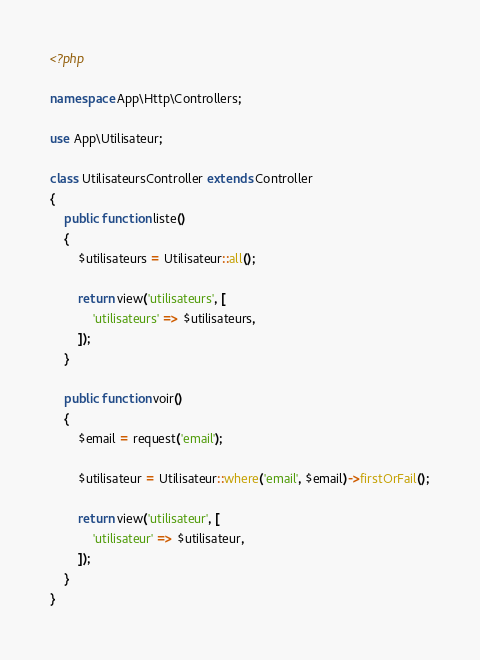Convert code to text. <code><loc_0><loc_0><loc_500><loc_500><_PHP_><?php

namespace App\Http\Controllers;

use App\Utilisateur;

class UtilisateursController extends Controller
{
    public function liste()
    {
        $utilisateurs = Utilisateur::all();

        return view('utilisateurs', [
            'utilisateurs' => $utilisateurs,
        ]);
    }

    public function voir()
    {
        $email = request('email');

        $utilisateur = Utilisateur::where('email', $email)->firstOrFail();

        return view('utilisateur', [
            'utilisateur' => $utilisateur,
        ]);
    }
}
</code> 